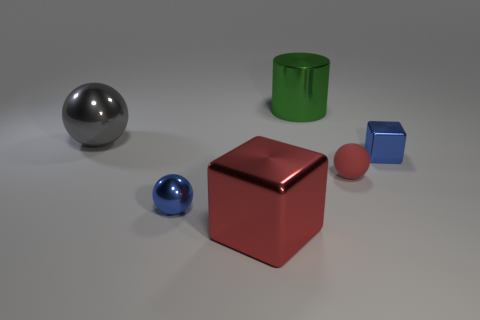The tiny rubber ball has what color?
Make the answer very short. Red. What number of objects are either blue shiny balls or tiny red rubber balls?
Provide a succinct answer. 2. Are there any other things that have the same material as the tiny red object?
Offer a very short reply. No. Are there fewer gray metallic objects to the right of the tiny blue block than blue metallic spheres?
Your response must be concise. Yes. Is the number of red shiny blocks that are right of the gray sphere greater than the number of small red matte things that are to the left of the big red shiny cube?
Offer a terse response. Yes. Is there anything else that has the same color as the matte object?
Your response must be concise. Yes. There is a block that is on the left side of the small block; what material is it?
Make the answer very short. Metal. Is the blue cube the same size as the gray shiny sphere?
Give a very brief answer. No. Is the color of the small block the same as the small shiny ball?
Offer a very short reply. Yes. The tiny metal thing that is behind the tiny blue metal thing that is on the left side of the small blue object that is right of the green metallic cylinder is what shape?
Make the answer very short. Cube. 